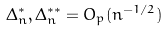<formula> <loc_0><loc_0><loc_500><loc_500>\Delta _ { n } ^ { * } , \Delta _ { n } ^ { * * } = O _ { p } ( n ^ { - 1 / 2 } )</formula> 